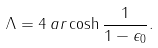Convert formula to latex. <formula><loc_0><loc_0><loc_500><loc_500>\Lambda = 4 \, a r \cosh \frac { 1 } { 1 - \epsilon _ { 0 } } .</formula> 